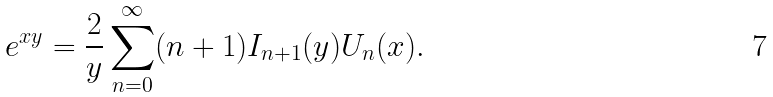<formula> <loc_0><loc_0><loc_500><loc_500>e ^ { x y } = \frac { 2 } { y } \sum _ { n = 0 } ^ { \infty } ( n + 1 ) I _ { n + 1 } ( y ) U _ { n } ( x ) .</formula> 